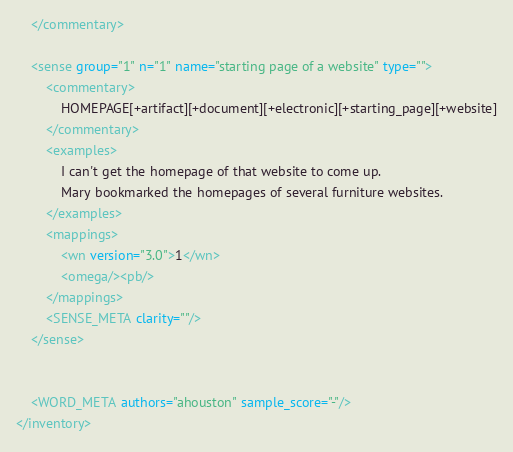<code> <loc_0><loc_0><loc_500><loc_500><_XML_>    </commentary>
    
    <sense group="1" n="1" name="starting page of a website" type="">
        <commentary>
            HOMEPAGE[+artifact][+document][+electronic][+starting_page][+website]
        </commentary>
        <examples>
            I can't get the homepage of that website to come up.
            Mary bookmarked the homepages of several furniture websites.
        </examples>
        <mappings>
            <wn version="3.0">1</wn>
            <omega/><pb/>
        </mappings>
        <SENSE_META clarity=""/>
    </sense>
     
    
    <WORD_META authors="ahouston" sample_score="-"/>
</inventory></code> 